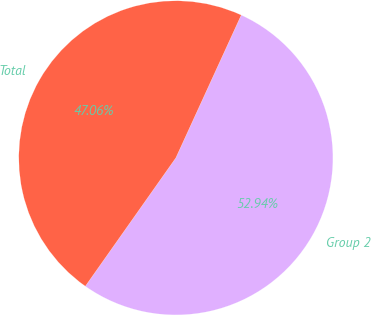Convert chart. <chart><loc_0><loc_0><loc_500><loc_500><pie_chart><fcel>Group 2<fcel>Total<nl><fcel>52.94%<fcel>47.06%<nl></chart> 